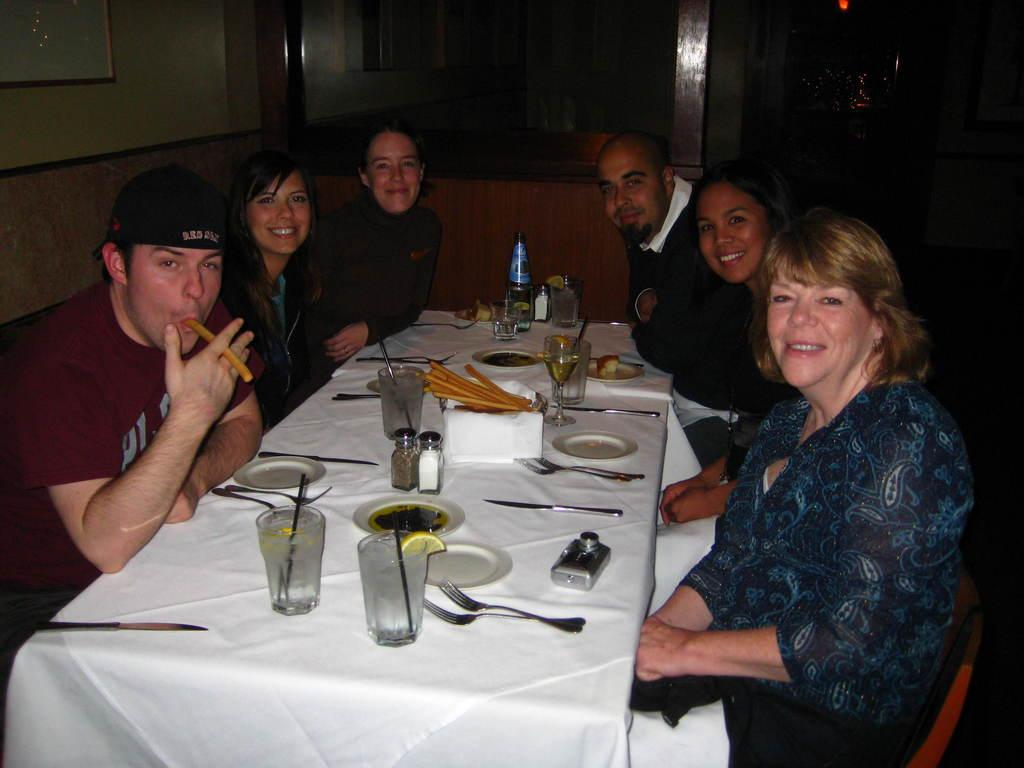How many men are in the image? There are 2 men in the image. How many women are in the image? There are 4 women in the image. What are the individuals doing in the image? All the individuals are sitting on chairs and smiling. What is in front of the individuals? There is a table in front of them. What can be seen on the table? There are items on the table. What type of crime is being committed in the image? There is no crime being committed in the image; the individuals are simply sitting and smiling. What color of paint is being used by the individuals in the image? There is no paint or painting activity present in the image. 